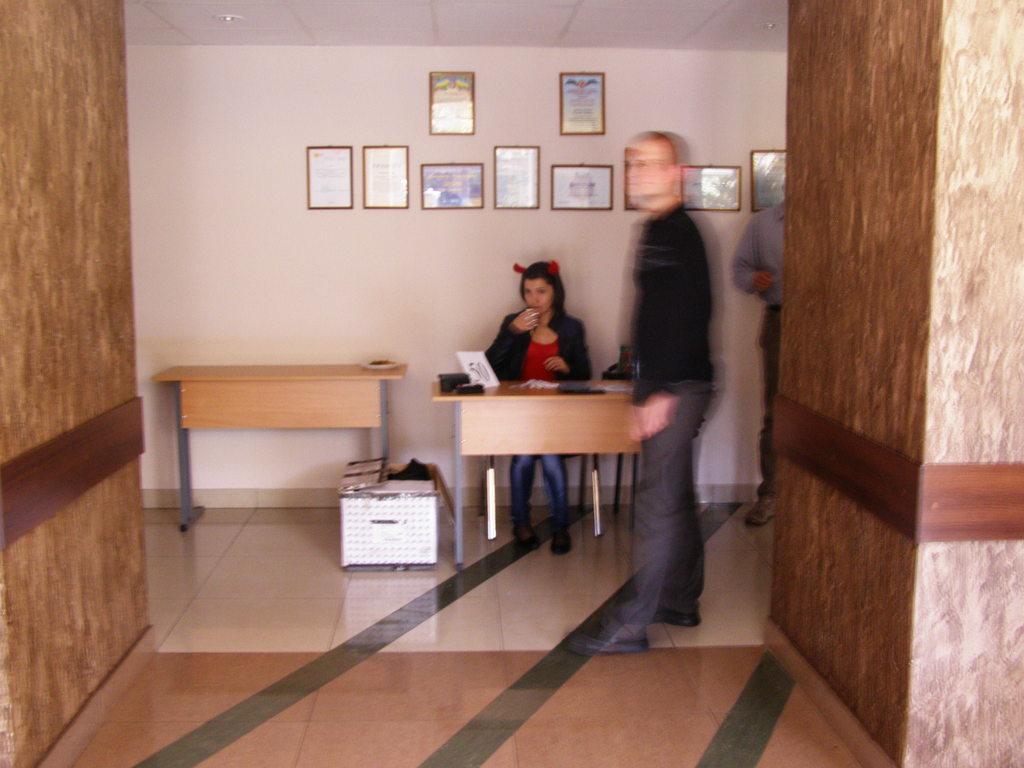Describe this image in one or two sentences. In this image there are two persons a person standing on the floor and a person sitting on the bench and at the top of the image there are paintings attached to the wall. 